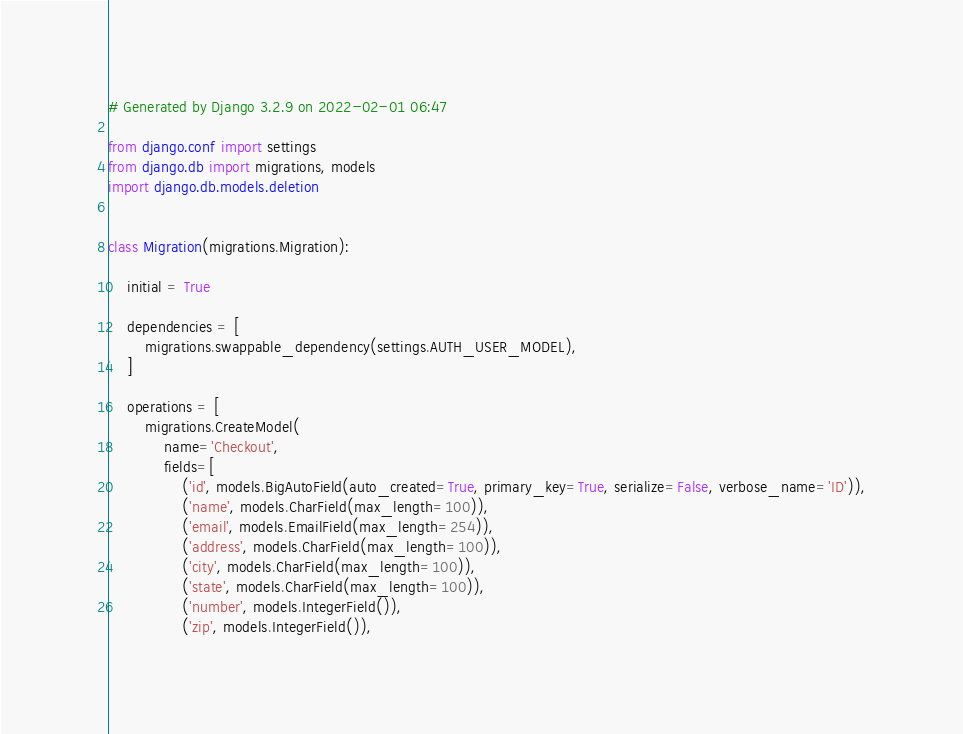<code> <loc_0><loc_0><loc_500><loc_500><_Python_># Generated by Django 3.2.9 on 2022-02-01 06:47

from django.conf import settings
from django.db import migrations, models
import django.db.models.deletion


class Migration(migrations.Migration):

    initial = True

    dependencies = [
        migrations.swappable_dependency(settings.AUTH_USER_MODEL),
    ]

    operations = [
        migrations.CreateModel(
            name='Checkout',
            fields=[
                ('id', models.BigAutoField(auto_created=True, primary_key=True, serialize=False, verbose_name='ID')),
                ('name', models.CharField(max_length=100)),
                ('email', models.EmailField(max_length=254)),
                ('address', models.CharField(max_length=100)),
                ('city', models.CharField(max_length=100)),
                ('state', models.CharField(max_length=100)),
                ('number', models.IntegerField()),
                ('zip', models.IntegerField()),</code> 